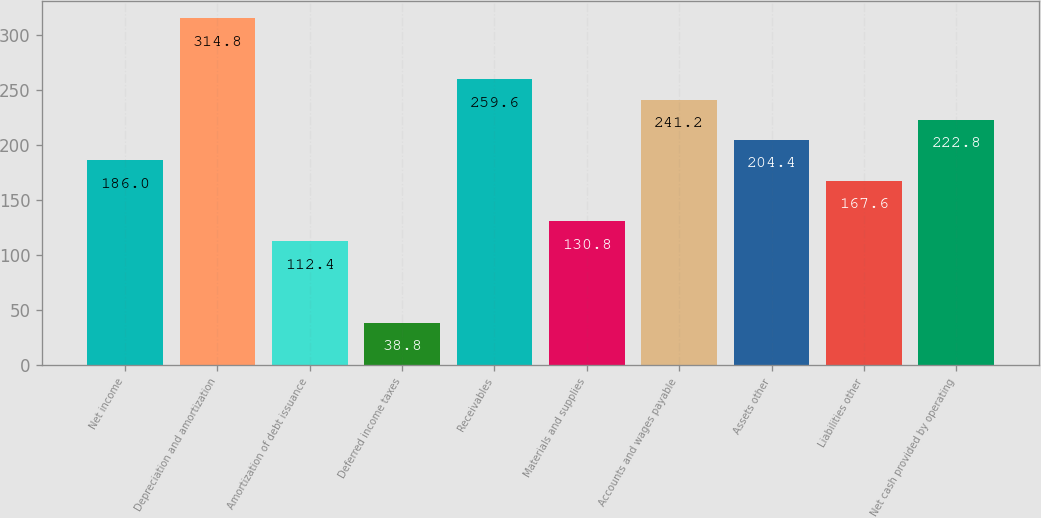Convert chart. <chart><loc_0><loc_0><loc_500><loc_500><bar_chart><fcel>Net income<fcel>Depreciation and amortization<fcel>Amortization of debt issuance<fcel>Deferred income taxes<fcel>Receivables<fcel>Materials and supplies<fcel>Accounts and wages payable<fcel>Assets other<fcel>Liabilities other<fcel>Net cash provided by operating<nl><fcel>186<fcel>314.8<fcel>112.4<fcel>38.8<fcel>259.6<fcel>130.8<fcel>241.2<fcel>204.4<fcel>167.6<fcel>222.8<nl></chart> 